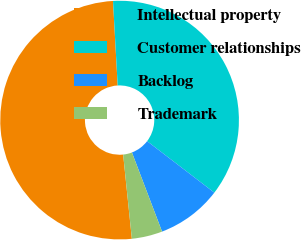Convert chart. <chart><loc_0><loc_0><loc_500><loc_500><pie_chart><fcel>Intellectual property<fcel>Customer relationships<fcel>Backlog<fcel>Trademark<nl><fcel>50.76%<fcel>36.28%<fcel>8.81%<fcel>4.15%<nl></chart> 